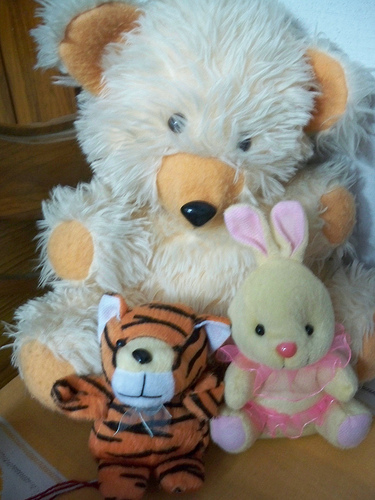<image>
Is there a tiger to the left of the bunny? Yes. From this viewpoint, the tiger is positioned to the left side relative to the bunny. 